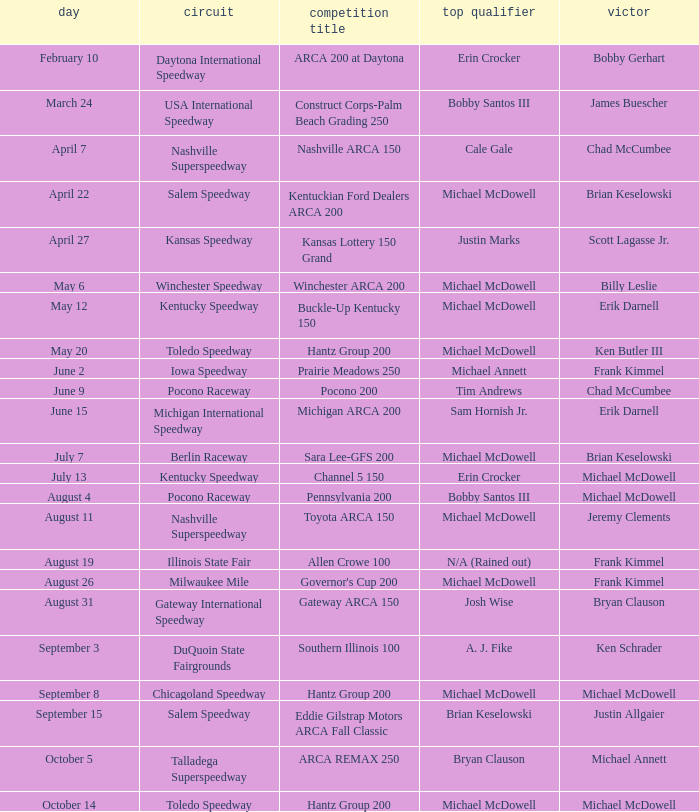Tell me the track for scott lagasse jr. Kansas Speedway. 